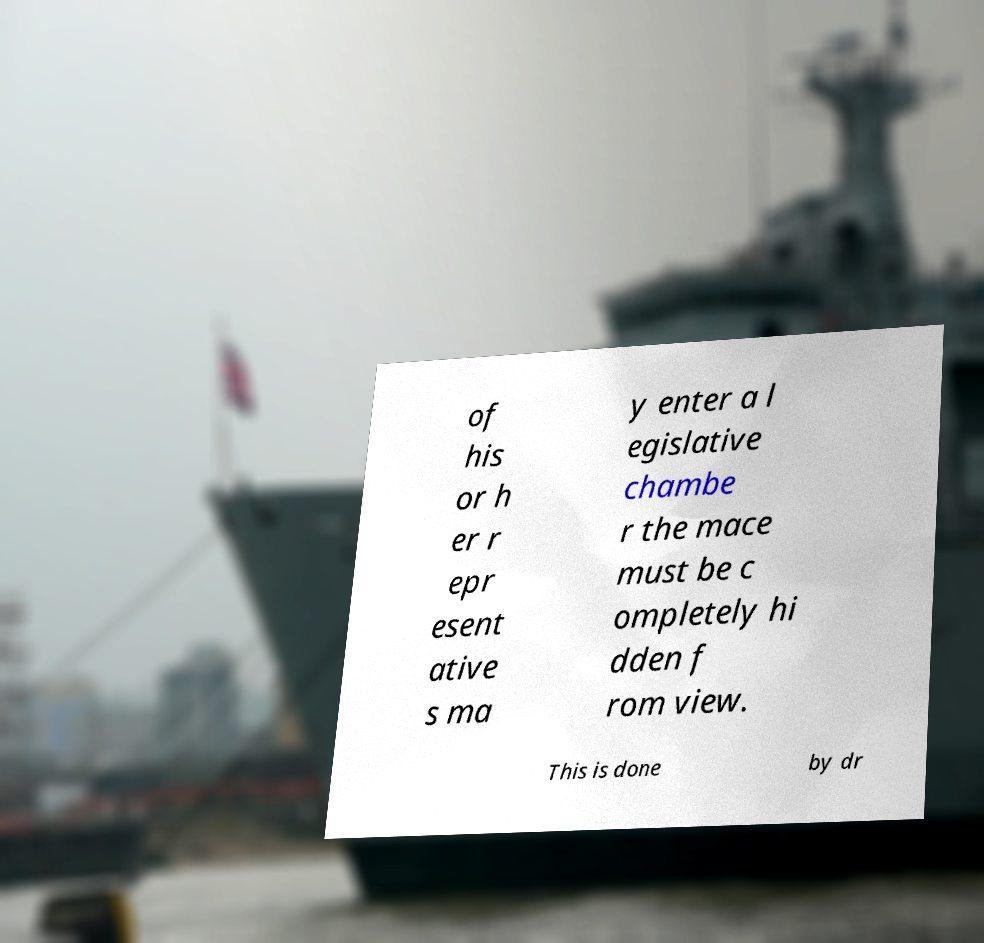Please identify and transcribe the text found in this image. of his or h er r epr esent ative s ma y enter a l egislative chambe r the mace must be c ompletely hi dden f rom view. This is done by dr 